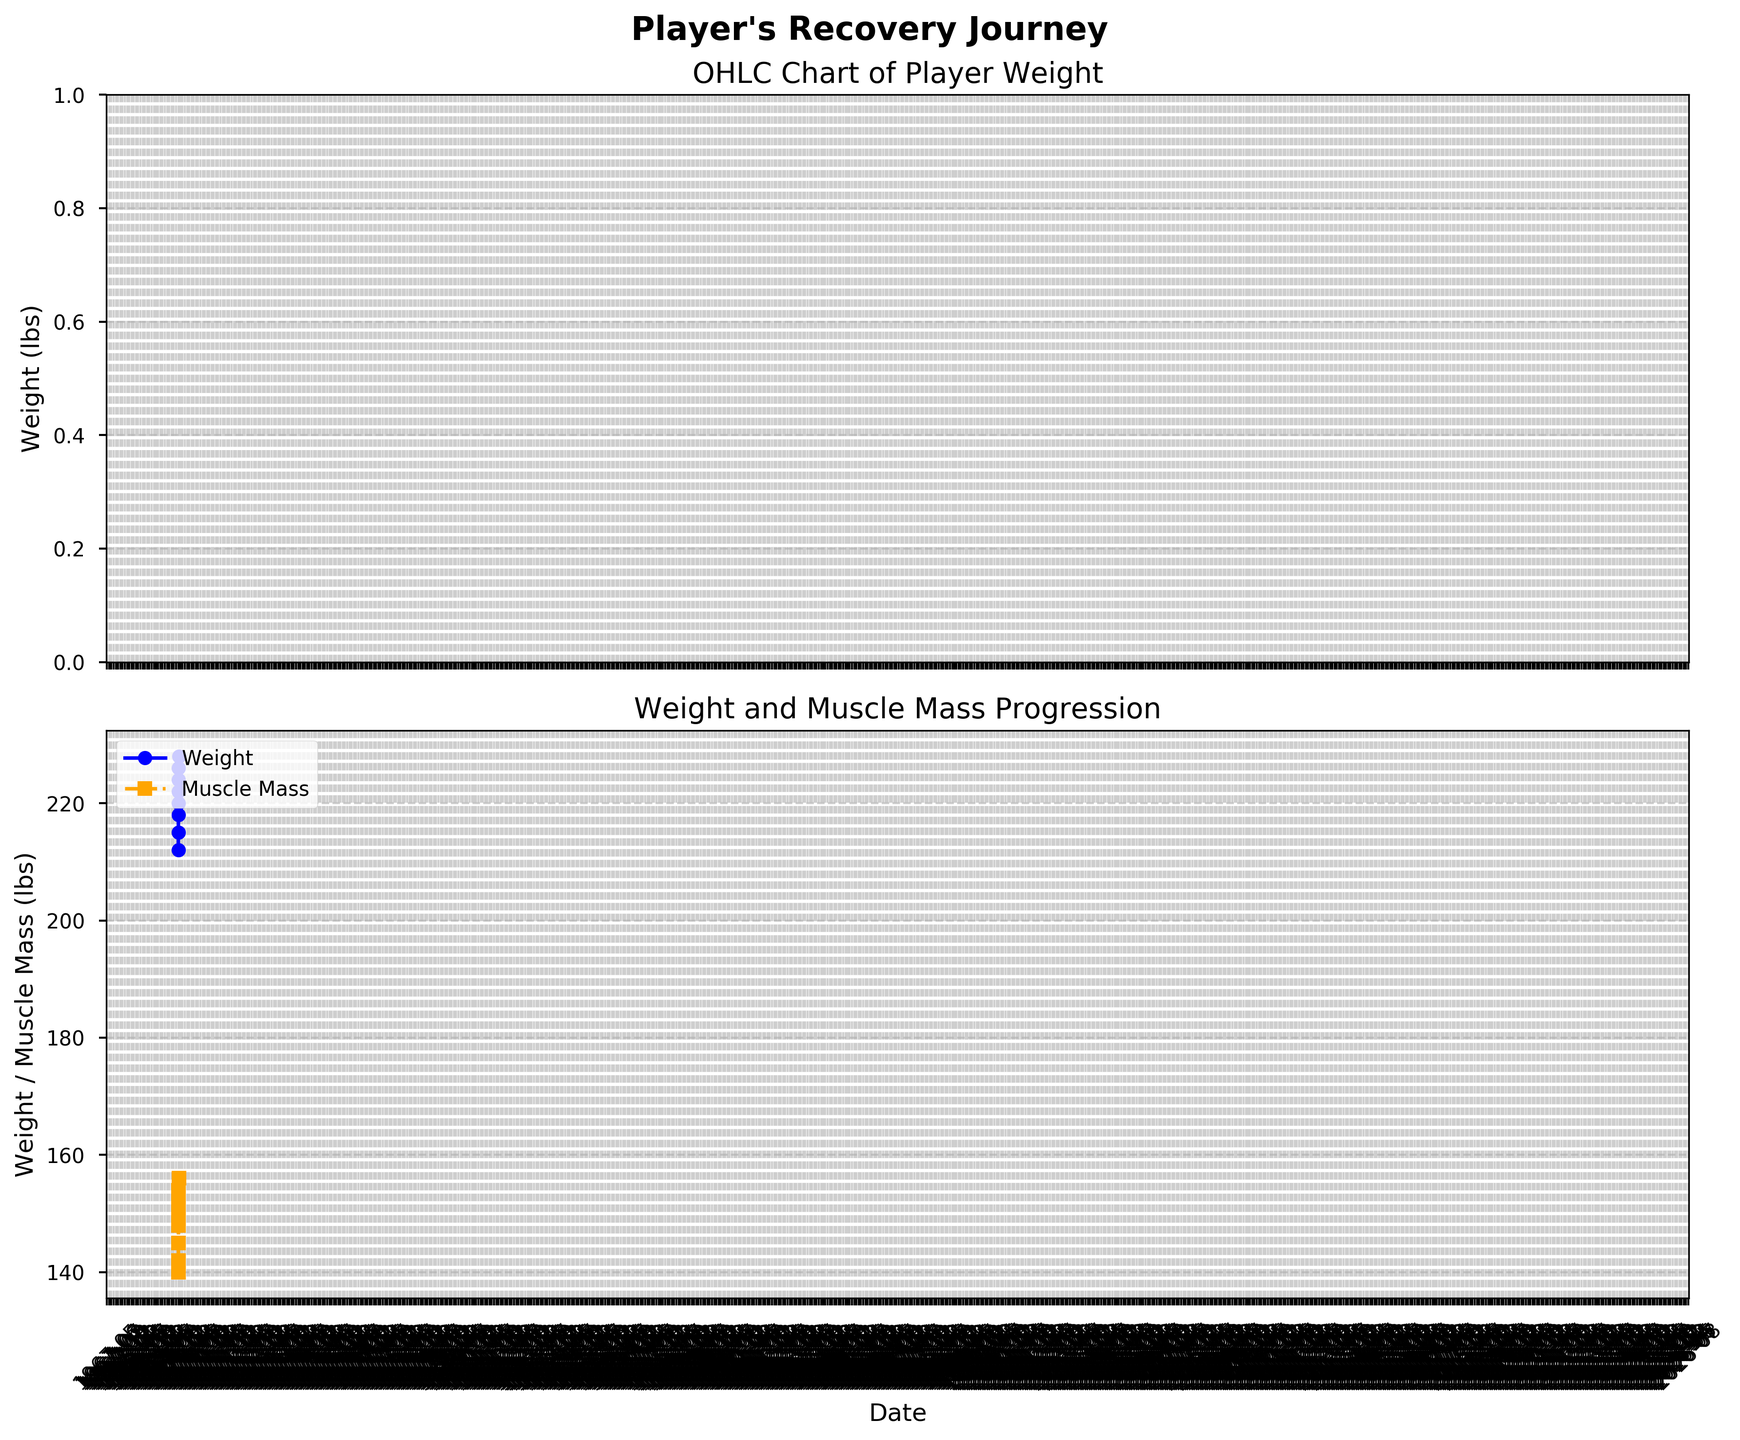What is the title of the first chart? The title is displayed prominently at the top of the first chart. It reads "OHLC Chart of Player Weight."
Answer: OHLC Chart of Player Weight How many months of data are shown in the figure? Look at the x-axis, it shows data points for each month from May 2023 to December 2023. Counting these months gives us the number of months represented.
Answer: 8 months What is the player's muscle mass in October 2023? On the second chart, locate October 2023 on the x-axis, then find the corresponding point on the orange dashed line. The y-axis value next to this point shows the muscle mass.
Answer: 152 lbs What was the player's weight at its highest in September 2023? In the OHLC chart, look for the rectangle corresponding to September 2023. The highest point of this rectangle gives the high weight for that month.
Answer: 225 lbs Did the player's weight increase or decrease from June to July 2023? Compare the "Close" values for June 2023 and July 2023. June closed at 215 lbs and July closed at 218 lbs, showing an increase.
Answer: Increase Which month showed the greatest increase in the player's muscle mass? On the second chart, observe the orange dashed line. The steepest upward segment indicates the greatest increase. Calculate monthly changes to confirm. From November 2023 to December 2023, muscle mass increased by 2 lbs, the highest among all months.
Answer: December 2023 What is the average muscle mass from May 2023 to December 2023? Sum all muscle mass values from May (140 lbs) to December (156 lbs), then divide by the number of months (8). (140 + 142 + 145 + 148 + 150 + 152 + 154 + 156) / 8 = 148.375
Answer: 148.375 lbs From which month onwards did the player’s weight remain above 220 lbs? In the OHLC chart, look at the "Close" values on the y-axis. Identify the first month where the "Close" value is above 220 lbs and continue to check subsequent months. Weight closes at 222 lbs in September 2023 and remains above 220 lbs afterward.
Answer: September 2023 What is the difference in the player's weight between the highest and lowest points in December 2023? In December 2023's OHLC chart data, the high weight is 230 lbs and the low weight is 224 lbs. Subtract the low from the high to find the difference. 230 - 224 = 6
Answer: 6 lbs How does the player's weight trend in the OHLC chart compare to the muscle mass trend over the same period? Both charts show a general upward trend from May 2023 to December 2023. The specific increase in weights and muscle mass follow a similar consistent pattern, both increasing over the months.
Answer: Both increased throughout 